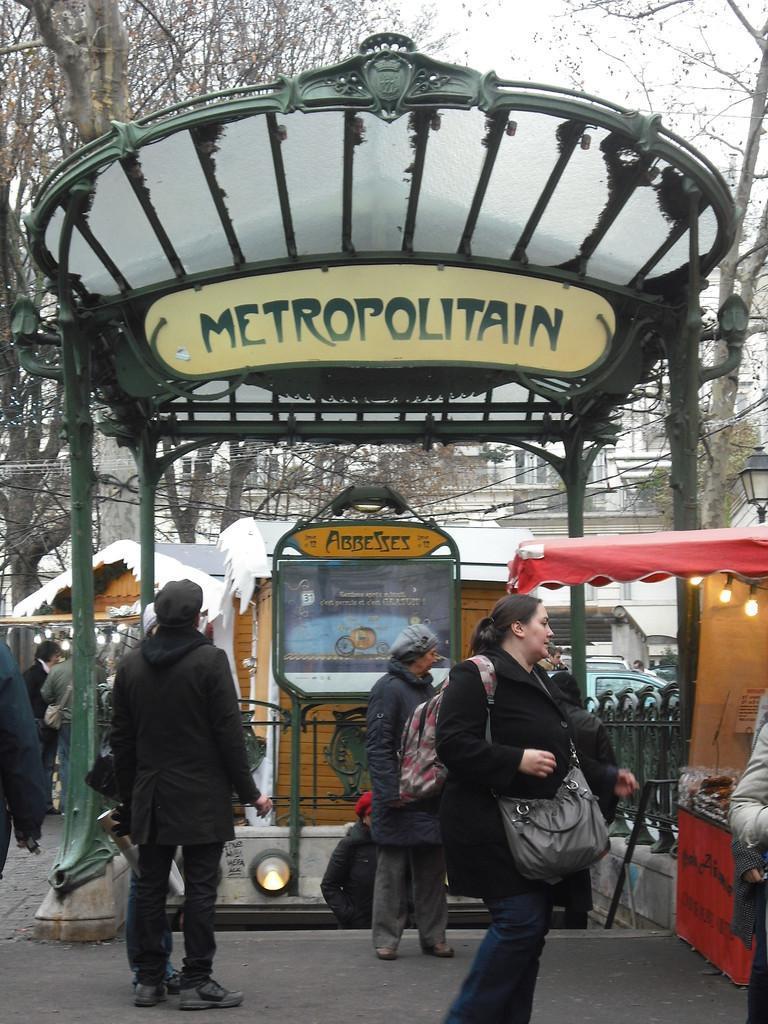Describe this image in one or two sentences. In this image there are people and we can see a shed. On the right we can see a tent and lights. In the background there are cottages, trees, buildings and sky. 